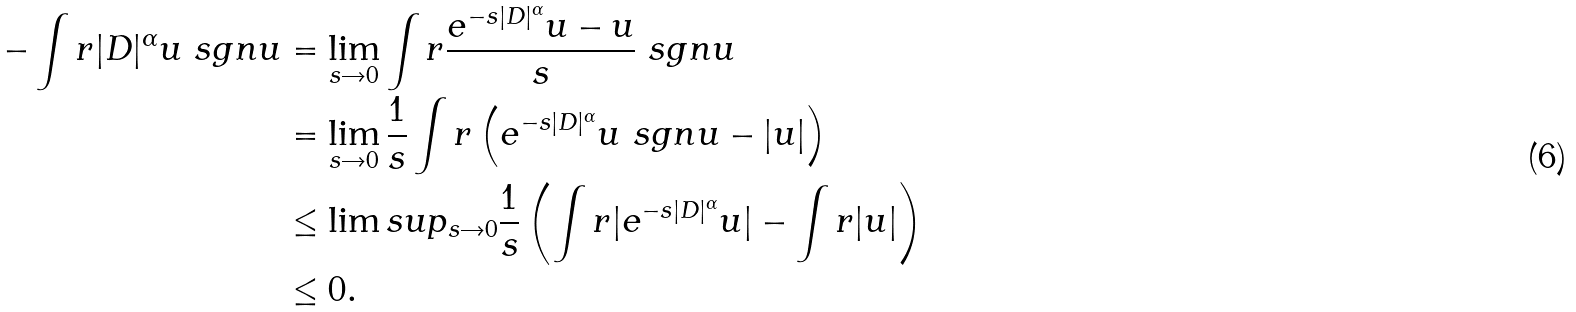<formula> <loc_0><loc_0><loc_500><loc_500>- \int r | D | ^ { \alpha } u \ s g n u & = \lim _ { s \rightarrow 0 } \int r \frac { e ^ { - s | D | ^ { \alpha } } u - u } { s } \ s g n u \\ & = \lim _ { s \rightarrow 0 } \frac { 1 } { s } \int r \left ( e ^ { - s | D | ^ { \alpha } } u \ s g n u - | u | \right ) \\ & \leq \lim s u p _ { s \rightarrow 0 } \frac { 1 } { s } \left ( \int r | e ^ { - s | D | ^ { \alpha } } u | - \int r | u | \right ) \\ & \leq 0 .</formula> 